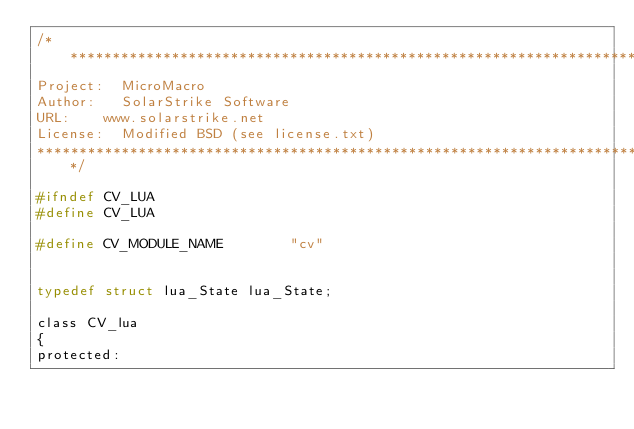<code> <loc_0><loc_0><loc_500><loc_500><_C_>/******************************************************************************
Project: 	MicroMacro
Author: 	SolarStrike Software
URL:		www.solarstrike.net
License:	Modified BSD (see license.txt)
******************************************************************************/

#ifndef CV_LUA
#define CV_LUA

#define CV_MODULE_NAME        "cv"


typedef struct lua_State lua_State;

class CV_lua
{
protected:</code> 